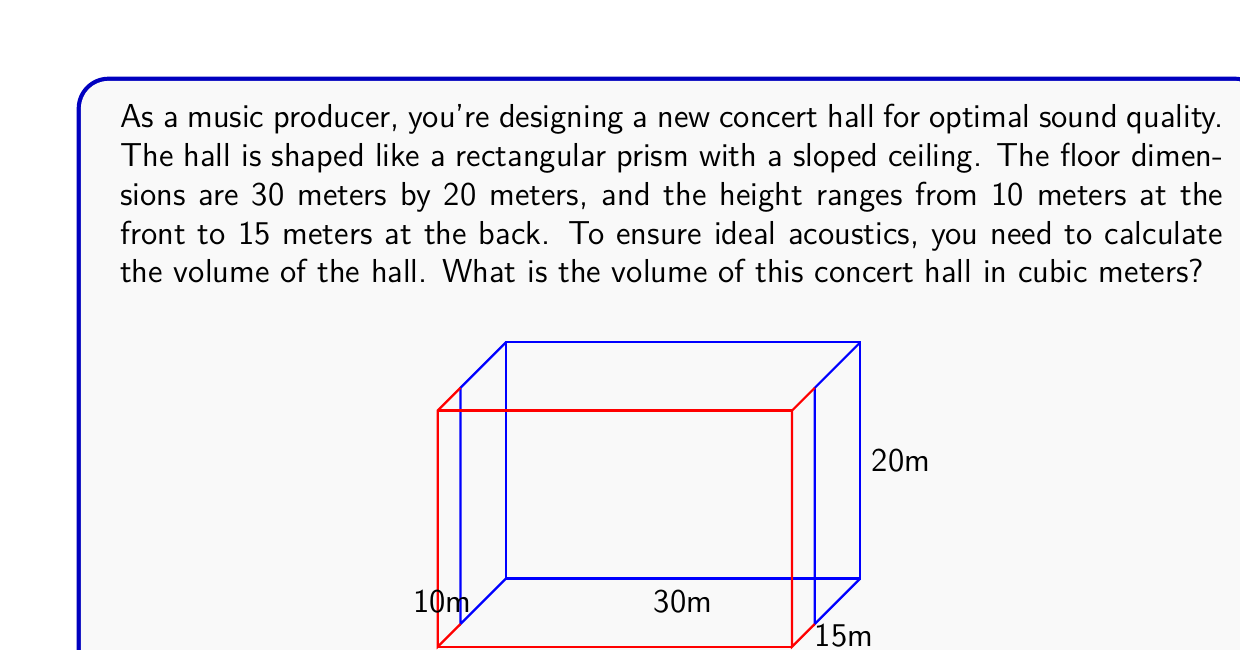What is the answer to this math problem? To calculate the volume of this concert hall, we need to consider its shape as a rectangular prism with a sloped ceiling. We can break this down into two steps:

1. Calculate the volume of a regular rectangular prism using the minimum height.
2. Add the volume of the wedge created by the sloped ceiling.

Step 1: Volume of the rectangular prism
$$ V_1 = length \times width \times minimum height $$
$$ V_1 = 30 \text{ m} \times 20 \text{ m} \times 10 \text{ m} = 6000 \text{ m}^3 $$

Step 2: Volume of the wedge
The wedge can be considered as half of a rectangular prism. Its volume is:
$$ V_2 = \frac{1}{2} \times length \times width \times height difference $$
$$ V_2 = \frac{1}{2} \times 30 \text{ m} \times 20 \text{ m} \times (15 \text{ m} - 10 \text{ m}) = 1500 \text{ m}^3 $$

Total volume:
$$ V_{total} = V_1 + V_2 = 6000 \text{ m}^3 + 1500 \text{ m}^3 = 7500 \text{ m}^3 $$

This calculation ensures that we account for both the main volume of the hall and the additional space created by the sloped ceiling, which is crucial for achieving the desired acoustic properties in the concert hall.
Answer: The volume of the concert hall is 7500 cubic meters. 